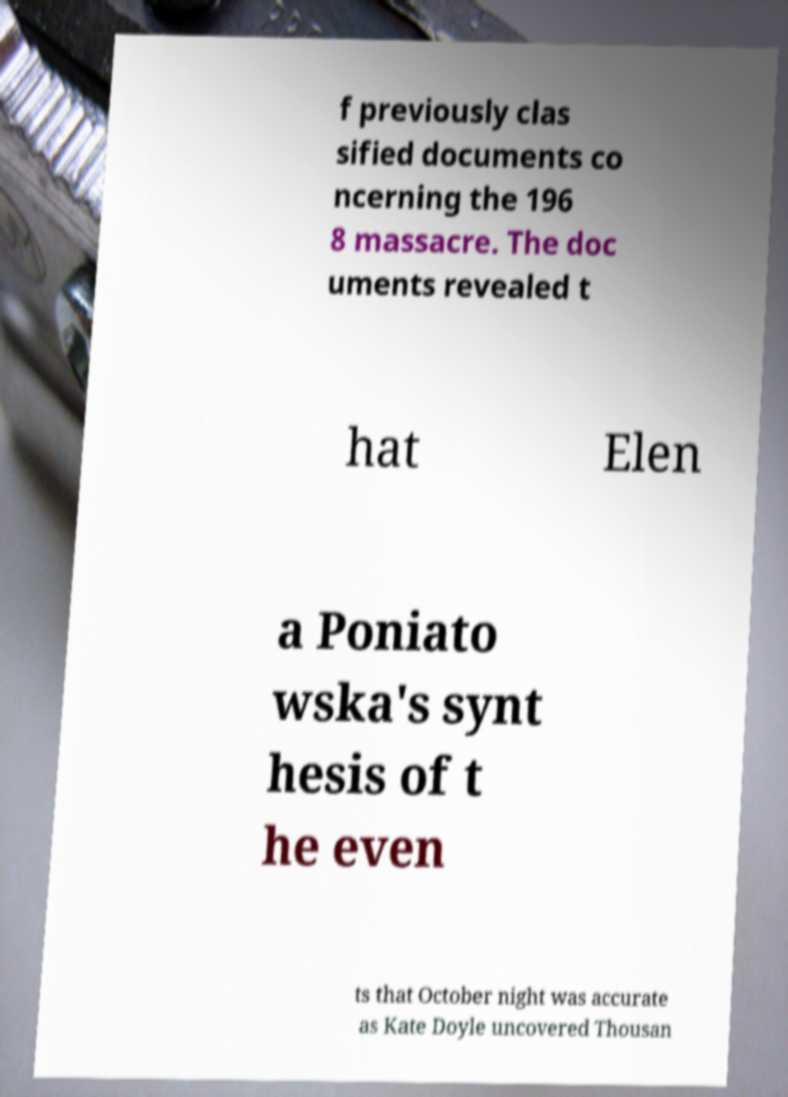Could you assist in decoding the text presented in this image and type it out clearly? f previously clas sified documents co ncerning the 196 8 massacre. The doc uments revealed t hat Elen a Poniato wska's synt hesis of t he even ts that October night was accurate as Kate Doyle uncovered Thousan 